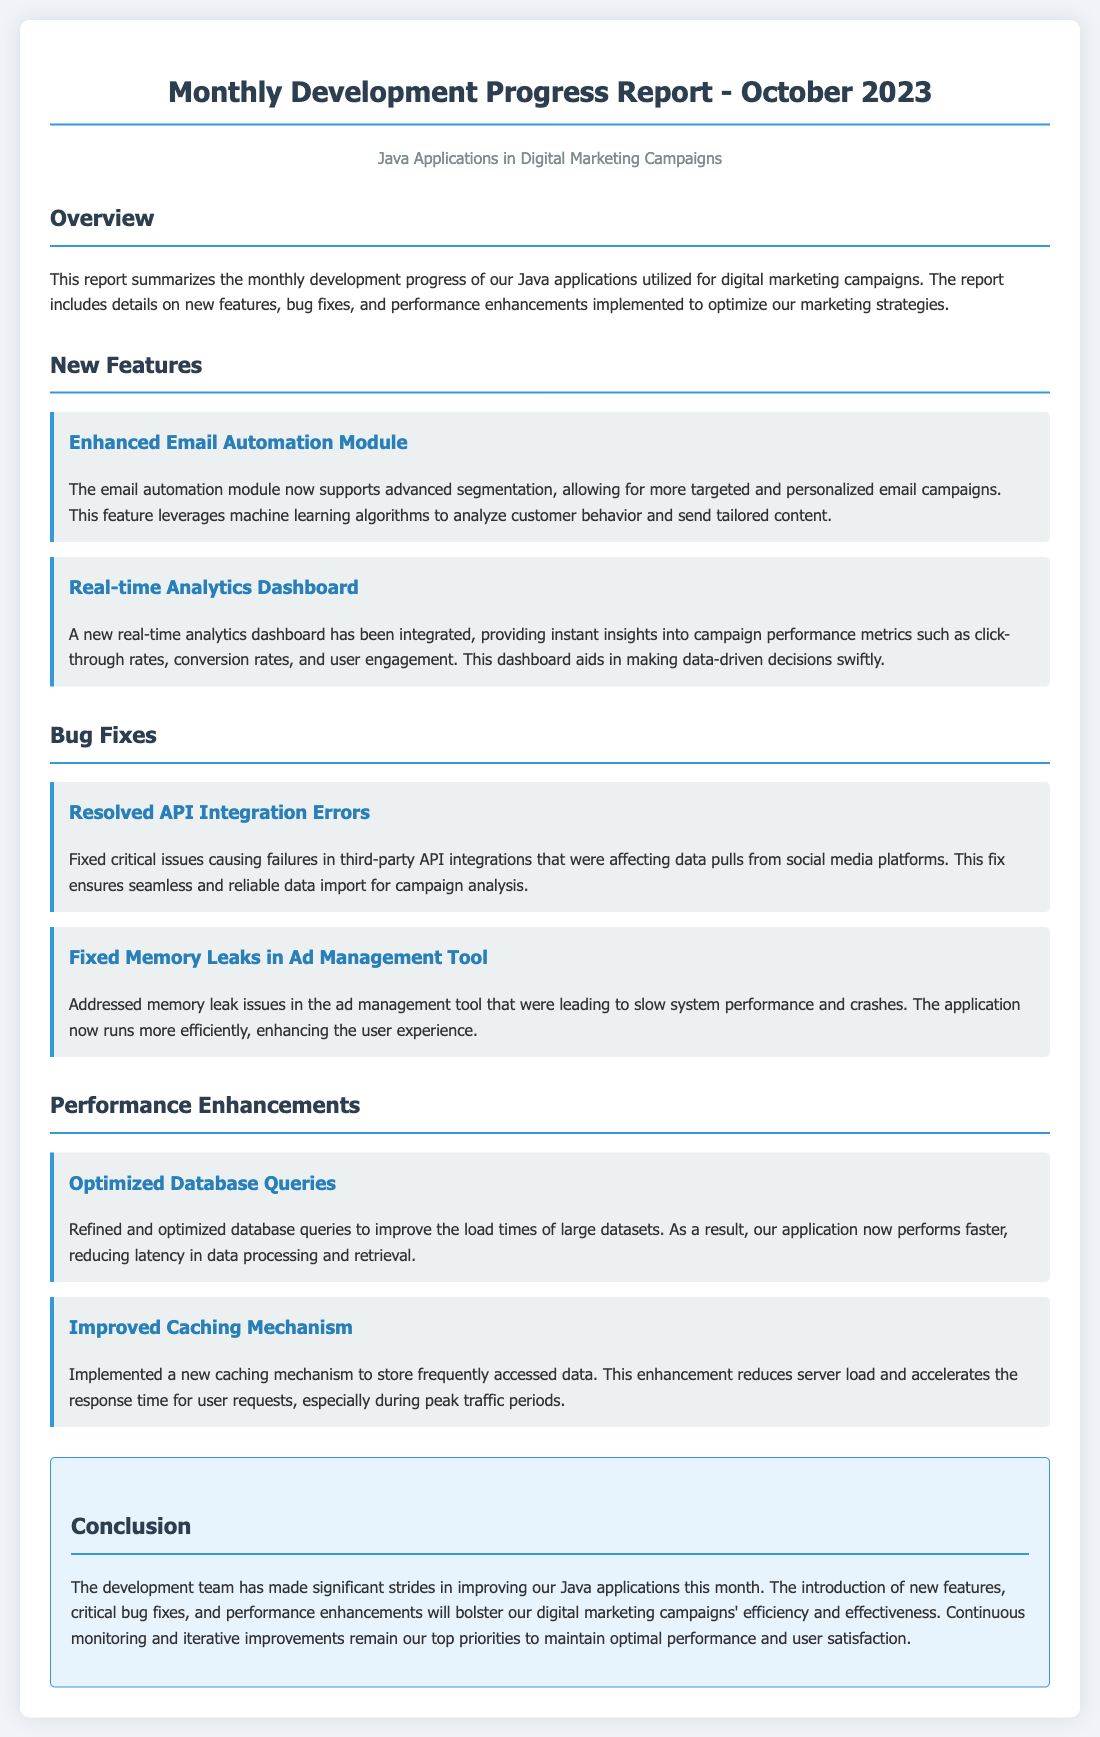What is the title of the report? The title of the report is indicated at the top of the document, in the h1 tag.
Answer: Monthly Development Progress Report - October 2023 What are the two new features highlighted in the report? The report mentions new features in separate items under the New Features section.
Answer: Enhanced Email Automation Module, Real-time Analytics Dashboard What critical issue was resolved in the bug fixes? The critical issue resolved is described in the first item of the Bug Fixes section.
Answer: API Integration Errors How many performance enhancements were implemented? The number of performance enhancements can be counted in the corresponding section.
Answer: Two What does the enhanced email automation module utilize for targeted campaigns? The document specifies the method used for this new feature in its description.
Answer: Machine learning algorithms What is the main focus of the conclusion section? The conclusion summarizes the overall developments and improvements for the month.
Answer: Significant strides in improving Java applications What is the purpose of the real-time analytics dashboard? The role of the analytics dashboard is outlined in its description within the New Features section.
Answer: Instant insights into campaign performance metrics What was improved in the ad management tool? The specific improvement in the ad management tool is detailed in the Bug Fixes section.
Answer: Memory leaks What benefit does the new caching mechanism provide? The benefits of the caching mechanism are explained in its performance enhancements description.
Answer: Reduces server load and accelerates response time 